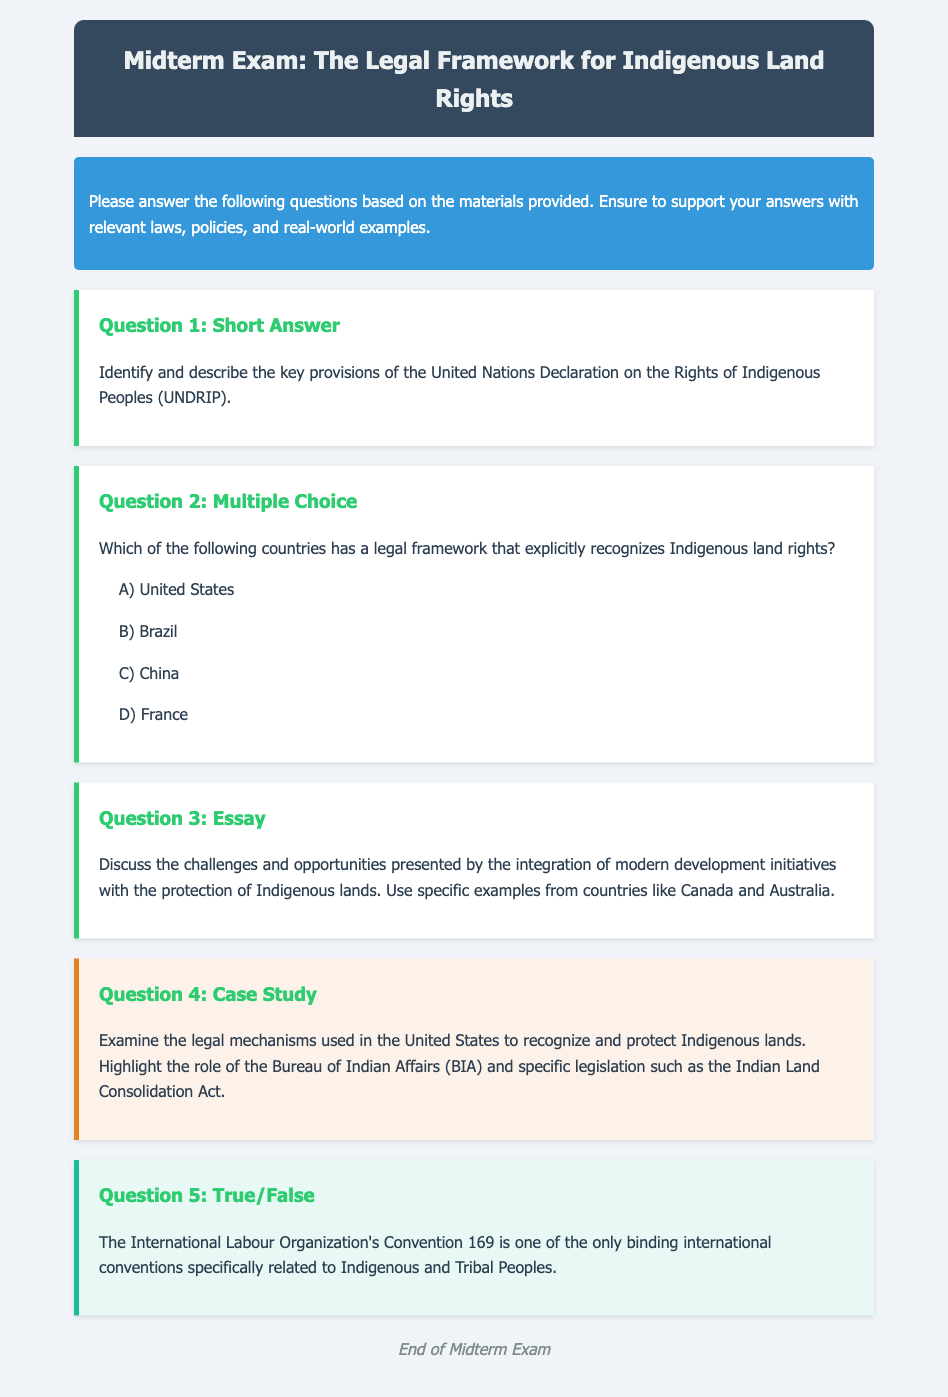What is the title of the document? The title of the document is prominently displayed in the header section of the rendered document.
Answer: Midterm Exam: The Legal Framework for Indigenous Land Rights How many questions are in the exam? The exam includes multiple types of questions that are listed in the main body of the document.
Answer: Five What is the background color of the instructions section? The color of the instructions section can be identified by inspecting the styling of that specific part of the document.
Answer: #3498db Which question type includes a case study? The type of the question that involves examining a specific legal case is clearly labeled in the document.
Answer: Question 4 What is the color of the true-false question section? The background color for the true-false question can be determined from the styling rules applied in the document.
Answer: #e8f8f5 What specific legislation is mentioned in Question 4? The legislation relevant to Indigenous land rights is explicitly referenced in the context of the United States within the question.
Answer: Indian Land Consolidation Act How many answer choices does the multiple-choice question provide? The number of options available for the multiple-choice question can be counted directly in the question section.
Answer: Four What international convention is mentioned in the true/false question? The specific international convention related to Indigenous and Tribal Peoples is directly referenced in the true/false section of the exam.
Answer: Convention 169 